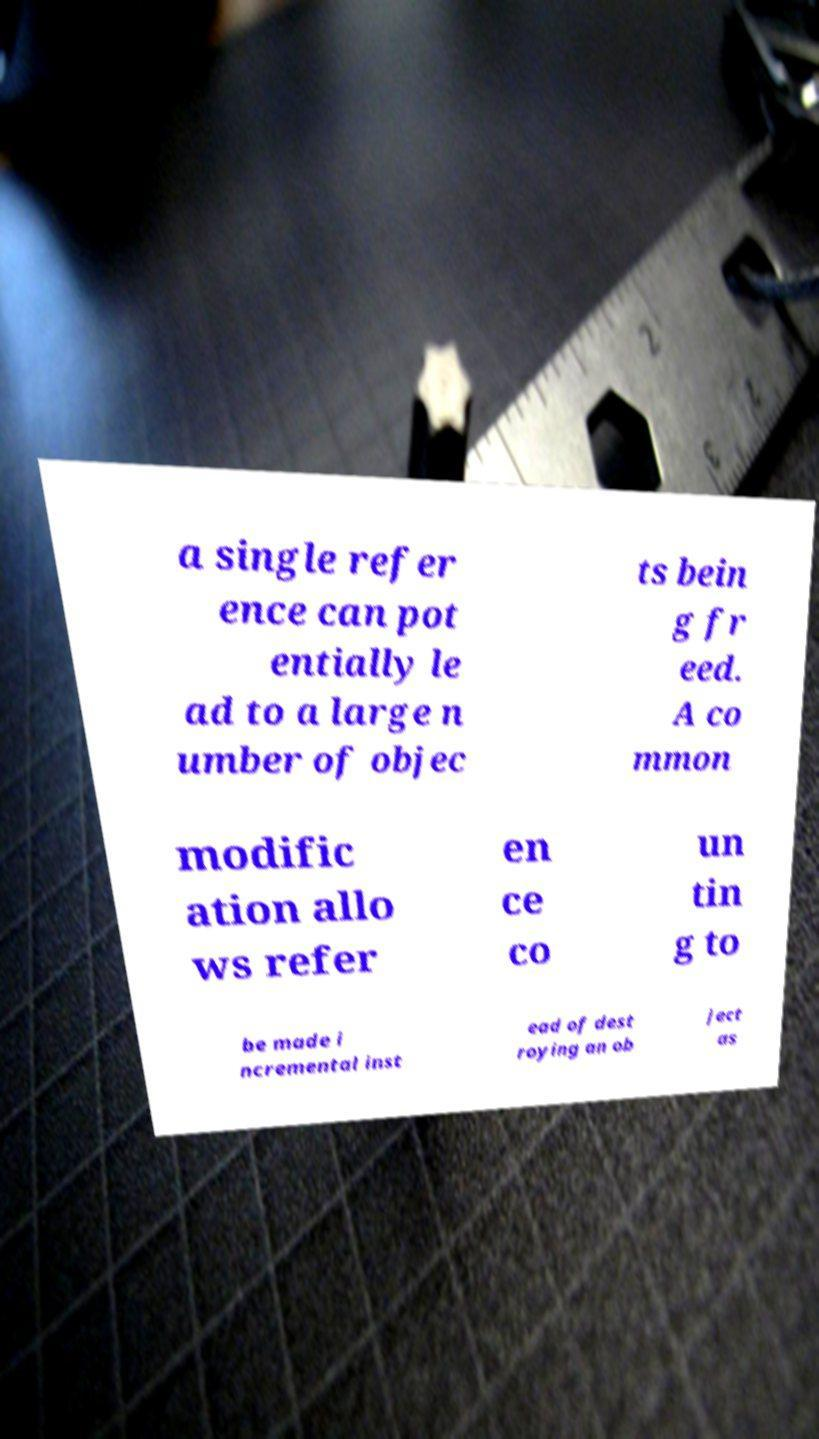Could you assist in decoding the text presented in this image and type it out clearly? a single refer ence can pot entially le ad to a large n umber of objec ts bein g fr eed. A co mmon modific ation allo ws refer en ce co un tin g to be made i ncremental inst ead of dest roying an ob ject as 